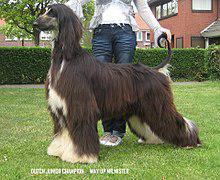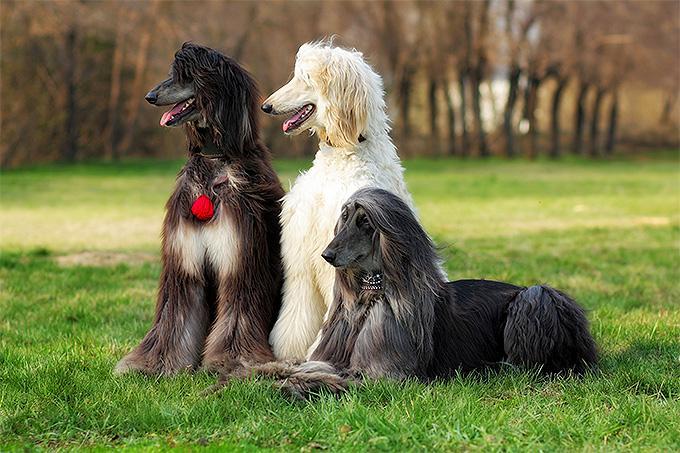The first image is the image on the left, the second image is the image on the right. Evaluate the accuracy of this statement regarding the images: "The dog in the image on the left is standing on all fours and facing left.". Is it true? Answer yes or no. Yes. The first image is the image on the left, the second image is the image on the right. Given the left and right images, does the statement "A hound poses in profile facing left, in the left image." hold true? Answer yes or no. Yes. 